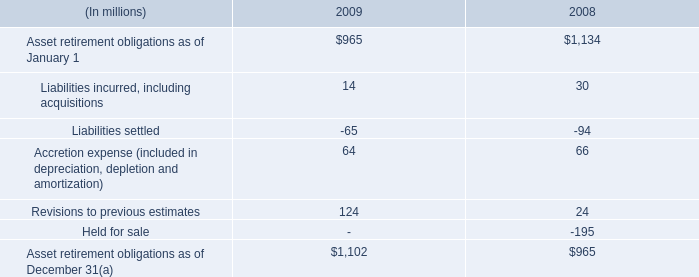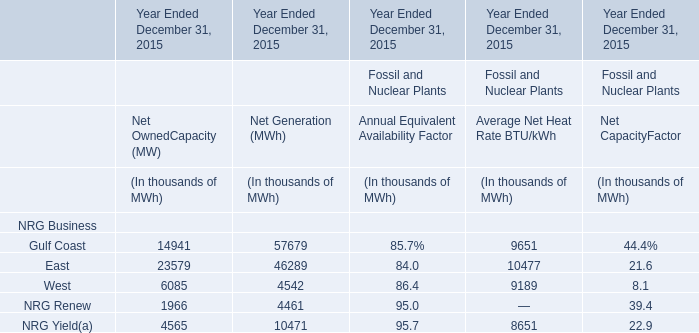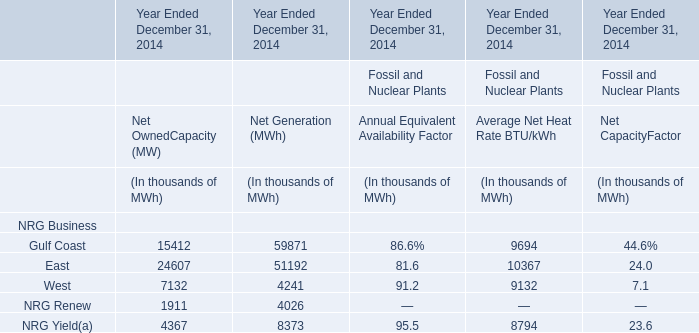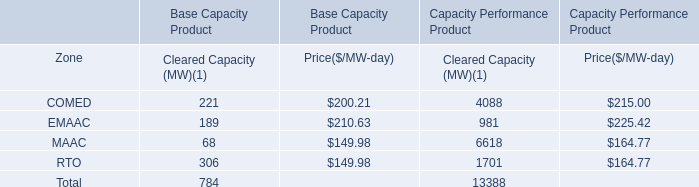In the section with largest amount of Average Net Heat Rate, what's the sum of West? (in thousand) 
Answer: 9189.0. 